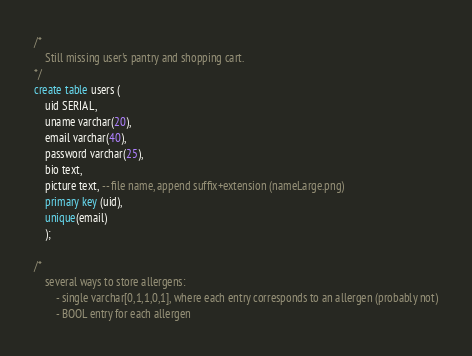Convert code to text. <code><loc_0><loc_0><loc_500><loc_500><_SQL_>/*
	Still missing user's pantry and shopping cart.
*/
create table users (
	uid SERIAL,
	uname varchar(20),
	email varchar(40),
	password varchar(25),
	bio text,
	picture text, -- file name, append suffix+extension (nameLarge.png)
	primary key (uid),
	unique(email)
	);

/*
	several ways to store allergens:
		- single varchar[0,1,1,0,1], where each entry corresponds to an allergen (probably not)
		- BOOL entry for each allergen
</code> 